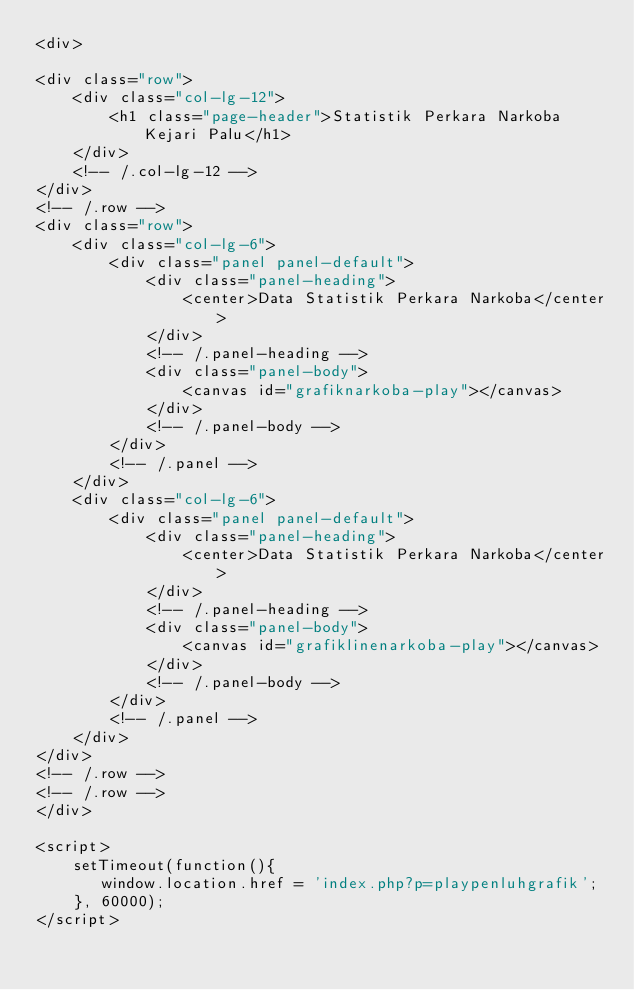<code> <loc_0><loc_0><loc_500><loc_500><_PHP_><div>

<div class="row">
    <div class="col-lg-12">
        <h1 class="page-header">Statistik Perkara Narkoba Kejari Palu</h1>
    </div>
    <!-- /.col-lg-12 -->
</div>
<!-- /.row -->
<div class="row">
    <div class="col-lg-6">
        <div class="panel panel-default">
            <div class="panel-heading">
                <center>Data Statistik Perkara Narkoba</center>
            </div>
            <!-- /.panel-heading -->
            <div class="panel-body">
                <canvas id="grafiknarkoba-play"></canvas>
            </div>
            <!-- /.panel-body -->
        </div>
        <!-- /.panel -->
    </div>
    <div class="col-lg-6">
        <div class="panel panel-default">
            <div class="panel-heading">
                <center>Data Statistik Perkara Narkoba</center>
            </div>
            <!-- /.panel-heading -->
            <div class="panel-body">
                <canvas id="grafiklinenarkoba-play"></canvas>
            </div>
            <!-- /.panel-body -->
        </div>
        <!-- /.panel -->
    </div>
</div>
<!-- /.row -->
<!-- /.row -->
</div>

<script>
    setTimeout(function(){
       window.location.href = 'index.php?p=playpenluhgrafik';
    }, 60000);
</script>
</code> 